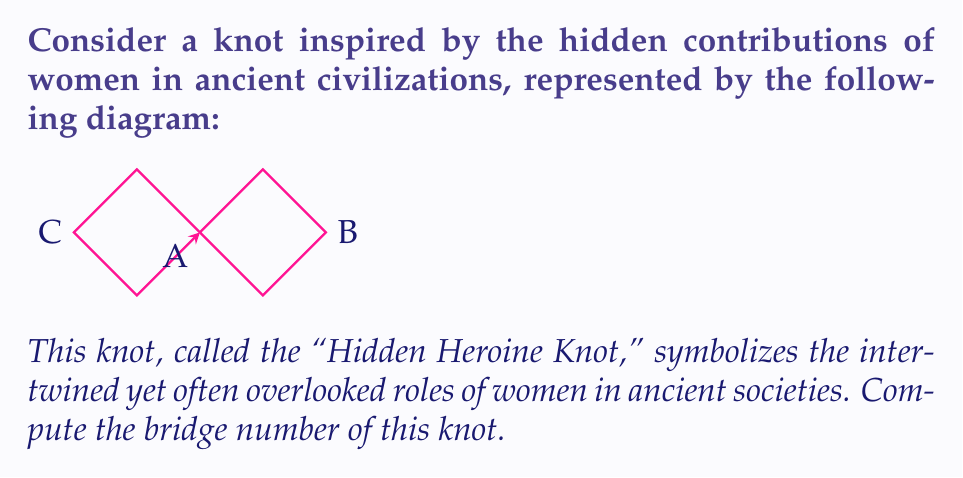Could you help me with this problem? To determine the bridge number of the Hidden Heroine Knot, we'll follow these steps:

1) The bridge number of a knot is defined as the minimum number of bridges needed in any bridge presentation of the knot.

2) A bridge in a knot diagram is an arc that goes over at least one crossing and whose endpoints are local maxima with respect to a chosen direction (usually vertical).

3) Examining the given diagram:
   - There are three local maxima: at points A, B, and C.
   - Each of these maxima corresponds to a bridge in this presentation.

4) To minimize the number of bridges:
   - We can rotate the knot so that point A is at the top.
   - This reduces the number of local maxima to two: one at A and one at either B or C.

5) No further reduction is possible without introducing new crossings or altering the knot type.

6) Therefore, the minimum number of bridges needed to present this knot is 2.

7) This 2-bridge presentation reflects the duality of visible and hidden contributions of women in ancient civilizations, symbolized by the two arches of the knot.

Thus, the bridge number of the Hidden Heroine Knot is 2.
Answer: 2 